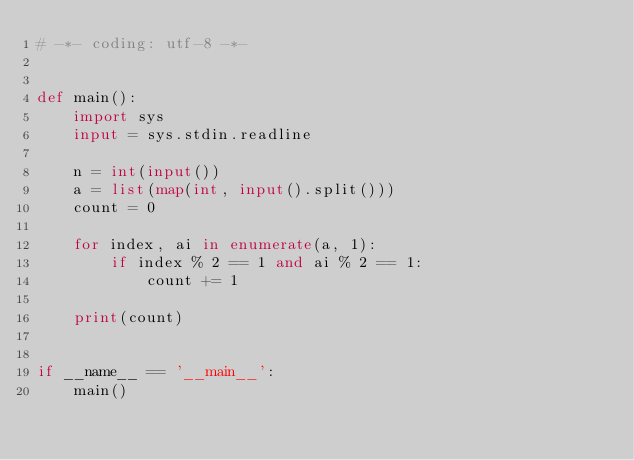<code> <loc_0><loc_0><loc_500><loc_500><_Python_># -*- coding: utf-8 -*-


def main():
    import sys
    input = sys.stdin.readline

    n = int(input())
    a = list(map(int, input().split()))
    count = 0

    for index, ai in enumerate(a, 1):
        if index % 2 == 1 and ai % 2 == 1:
            count += 1

    print(count)


if __name__ == '__main__':
    main()
</code> 